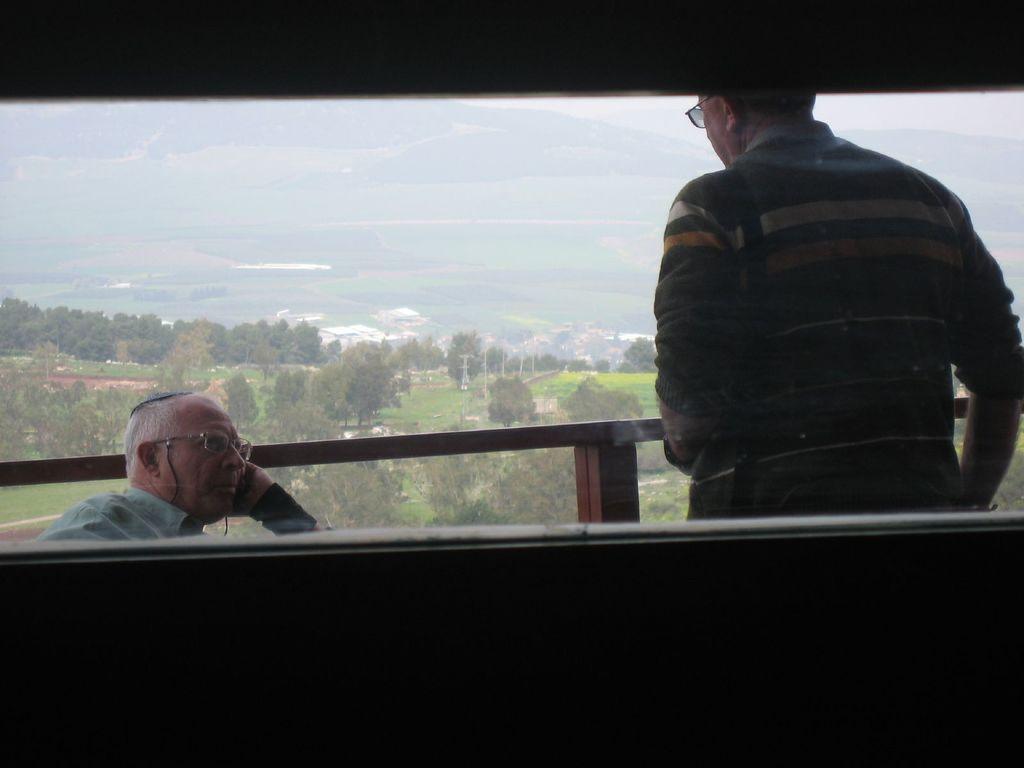Can you describe this image briefly? On the left side, there is a person in a shirt, wearing a spectacle and sitting. On the right side, there is a person wearing a spectacle and standing. Beside them, there is a fence. In the background, there are trees and plants on a ground and there is a mountain. 